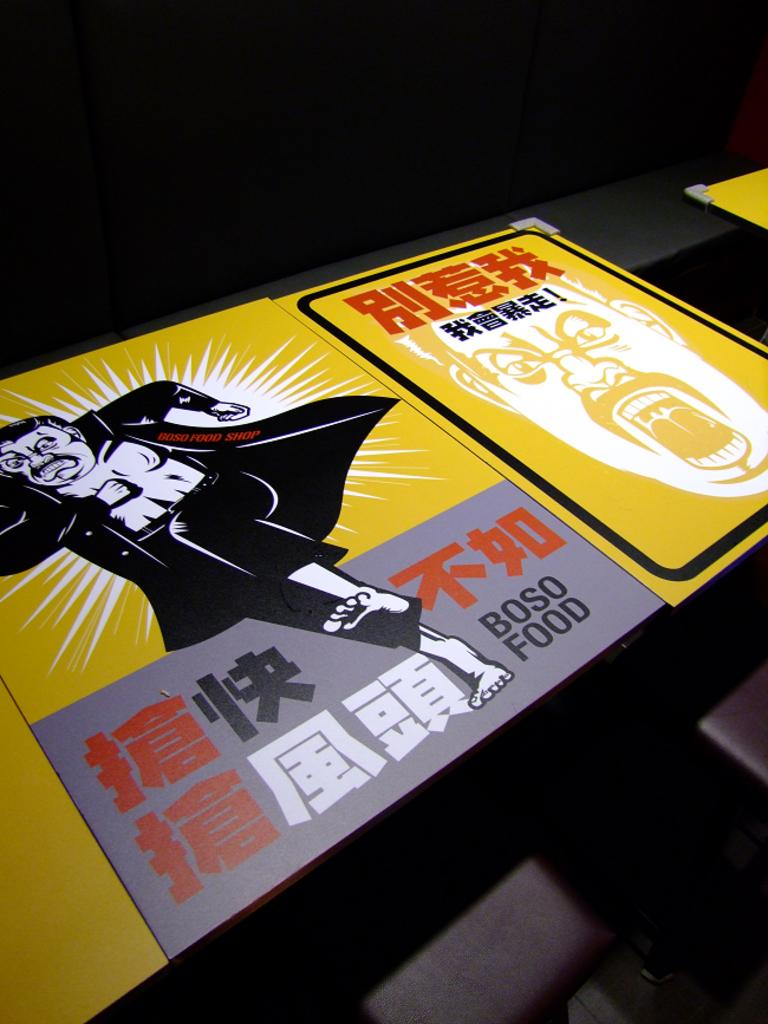Provide a one-sentence caption for the provided image. A yellow purple and black box with a man in all black wearing a cape, the box states Boso food. 